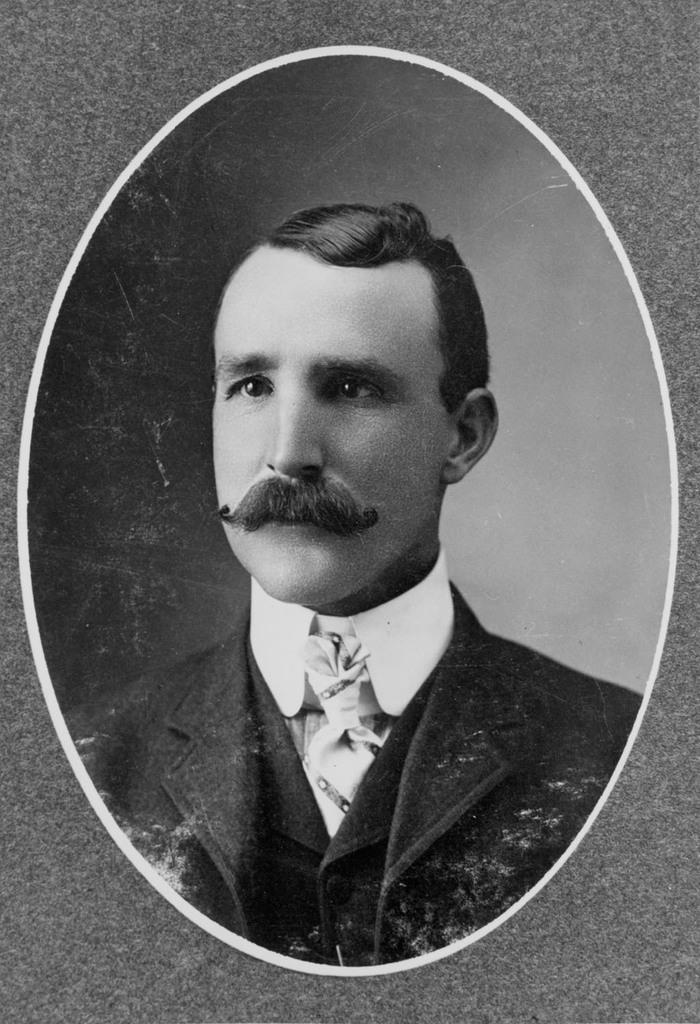What object is present in the image that typically holds a picture? There is a photo frame in the image. What can be seen inside the photo frame? The photo frame contains a picture of a man. What type of stitch is being used to hold the man's picture in the photo frame? There is no mention of a stitch or any method of holding the picture in the photo frame in the image. 